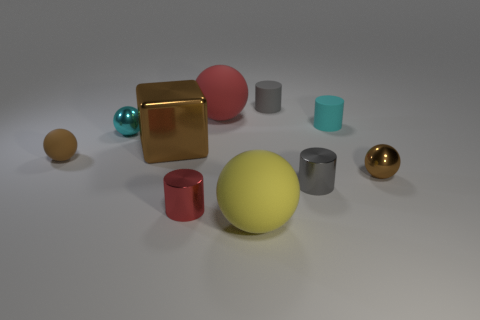There is a tiny matte object that is the same color as the metal cube; what is its shape?
Your answer should be compact. Sphere. There is a shiny thing that is the same color as the large metal cube; what is its size?
Provide a short and direct response. Small. There is another sphere that is the same size as the red rubber ball; what is its color?
Ensure brevity in your answer.  Yellow. Is the shape of the brown rubber object the same as the big brown object?
Ensure brevity in your answer.  No. What material is the gray cylinder that is in front of the large red sphere?
Offer a very short reply. Metal. The large metallic object has what color?
Provide a succinct answer. Brown. There is a brown metallic thing to the right of the big metal thing; does it have the same size as the cylinder in front of the small gray shiny object?
Make the answer very short. Yes. What is the size of the object that is both in front of the small gray shiny cylinder and left of the big red matte object?
Provide a succinct answer. Small. What is the color of the tiny rubber object that is the same shape as the big yellow matte thing?
Offer a very short reply. Brown. Are there more big red things in front of the brown metallic cube than small cyan things behind the tiny brown shiny thing?
Provide a short and direct response. No. 